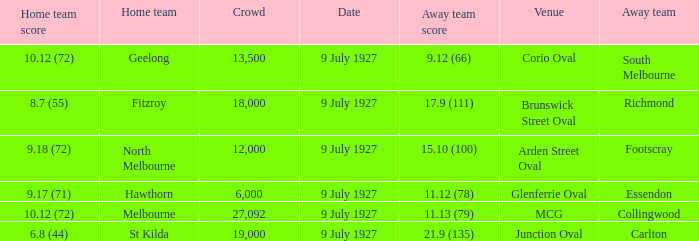How big was the crowd when the away team was Richmond? 18000.0. 